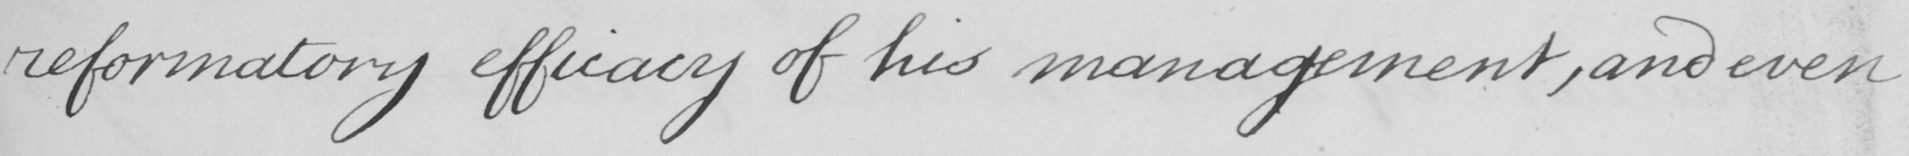Can you tell me what this handwritten text says? reformatory efficacy of his management , and even 